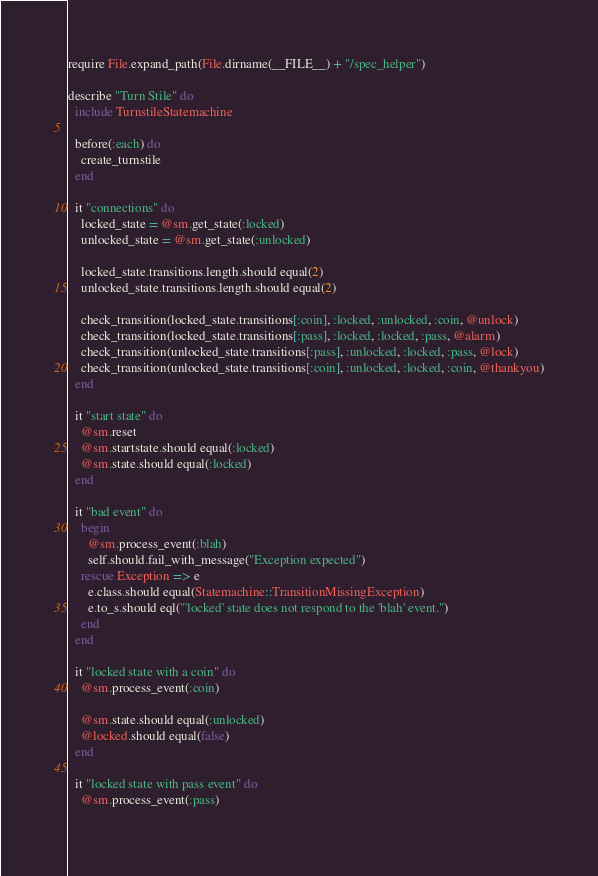Convert code to text. <code><loc_0><loc_0><loc_500><loc_500><_Ruby_>require File.expand_path(File.dirname(__FILE__) + "/spec_helper")

describe "Turn Stile" do
  include TurnstileStatemachine
  
  before(:each) do
    create_turnstile
  end
  
  it "connections" do
    locked_state = @sm.get_state(:locked)
    unlocked_state = @sm.get_state(:unlocked)
    
    locked_state.transitions.length.should equal(2)
    unlocked_state.transitions.length.should equal(2)
    
    check_transition(locked_state.transitions[:coin], :locked, :unlocked, :coin, @unlock)
    check_transition(locked_state.transitions[:pass], :locked, :locked, :pass, @alarm)
    check_transition(unlocked_state.transitions[:pass], :unlocked, :locked, :pass, @lock)
    check_transition(unlocked_state.transitions[:coin], :unlocked, :locked, :coin, @thankyou)
  end
  
  it "start state" do
    @sm.reset
    @sm.startstate.should equal(:locked)
    @sm.state.should equal(:locked)
  end
  
  it "bad event" do
    begin
      @sm.process_event(:blah)
      self.should.fail_with_message("Exception expected")
    rescue Exception => e
      e.class.should equal(Statemachine::TransitionMissingException)
      e.to_s.should eql("'locked' state does not respond to the 'blah' event.")
    end
  end
  
  it "locked state with a coin" do
    @sm.process_event(:coin)
    
    @sm.state.should equal(:unlocked)
    @locked.should equal(false)
  end
  
  it "locked state with pass event" do
    @sm.process_event(:pass)
    </code> 